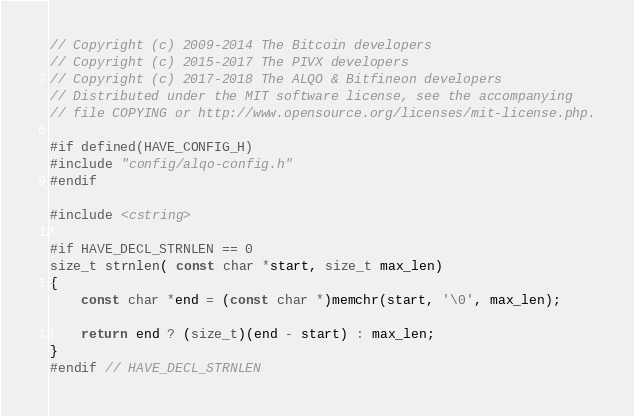Convert code to text. <code><loc_0><loc_0><loc_500><loc_500><_C++_>// Copyright (c) 2009-2014 The Bitcoin developers
// Copyright (c) 2015-2017 The PIVX developers// Copyright (c) 2017-2018 The ALQO & Bitfineon developers
// Distributed under the MIT software license, see the accompanying
// file COPYING or http://www.opensource.org/licenses/mit-license.php.

#if defined(HAVE_CONFIG_H)
#include "config/alqo-config.h"
#endif

#include <cstring>

#if HAVE_DECL_STRNLEN == 0
size_t strnlen( const char *start, size_t max_len)
{
    const char *end = (const char *)memchr(start, '\0', max_len);

    return end ? (size_t)(end - start) : max_len;
}
#endif // HAVE_DECL_STRNLEN
</code> 